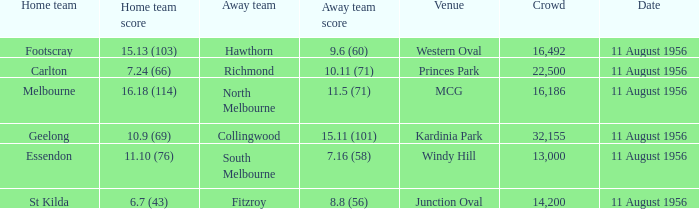What home team has a score of 16.18 (114)? Melbourne. 